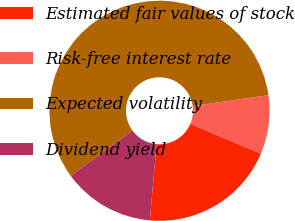Convert chart. <chart><loc_0><loc_0><loc_500><loc_500><pie_chart><fcel>Estimated fair values of stock<fcel>Risk-free interest rate<fcel>Expected volatility<fcel>Dividend yield<nl><fcel>20.03%<fcel>8.64%<fcel>57.79%<fcel>13.55%<nl></chart> 